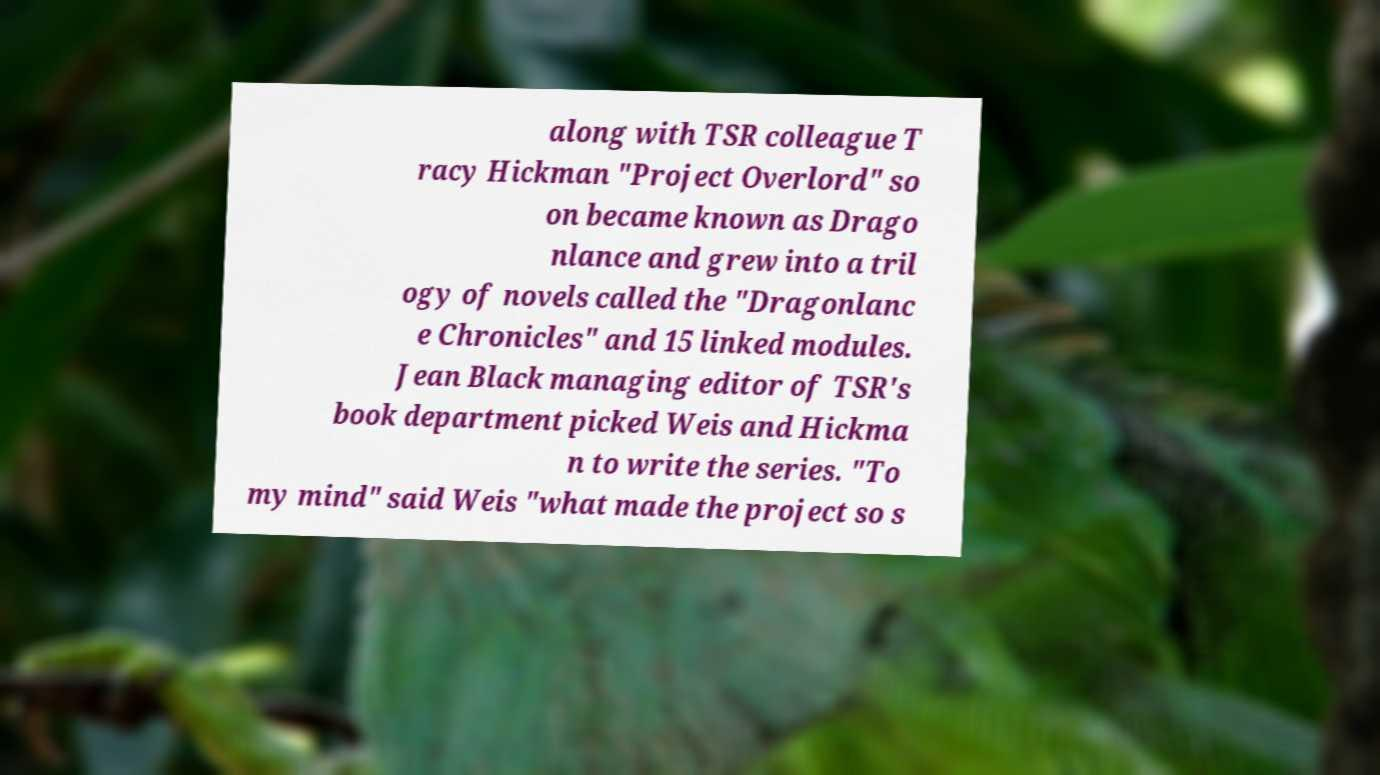Could you extract and type out the text from this image? along with TSR colleague T racy Hickman "Project Overlord" so on became known as Drago nlance and grew into a tril ogy of novels called the "Dragonlanc e Chronicles" and 15 linked modules. Jean Black managing editor of TSR's book department picked Weis and Hickma n to write the series. "To my mind" said Weis "what made the project so s 